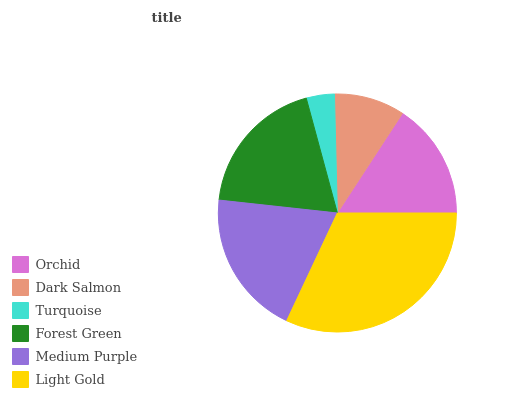Is Turquoise the minimum?
Answer yes or no. Yes. Is Light Gold the maximum?
Answer yes or no. Yes. Is Dark Salmon the minimum?
Answer yes or no. No. Is Dark Salmon the maximum?
Answer yes or no. No. Is Orchid greater than Dark Salmon?
Answer yes or no. Yes. Is Dark Salmon less than Orchid?
Answer yes or no. Yes. Is Dark Salmon greater than Orchid?
Answer yes or no. No. Is Orchid less than Dark Salmon?
Answer yes or no. No. Is Forest Green the high median?
Answer yes or no. Yes. Is Orchid the low median?
Answer yes or no. Yes. Is Medium Purple the high median?
Answer yes or no. No. Is Light Gold the low median?
Answer yes or no. No. 